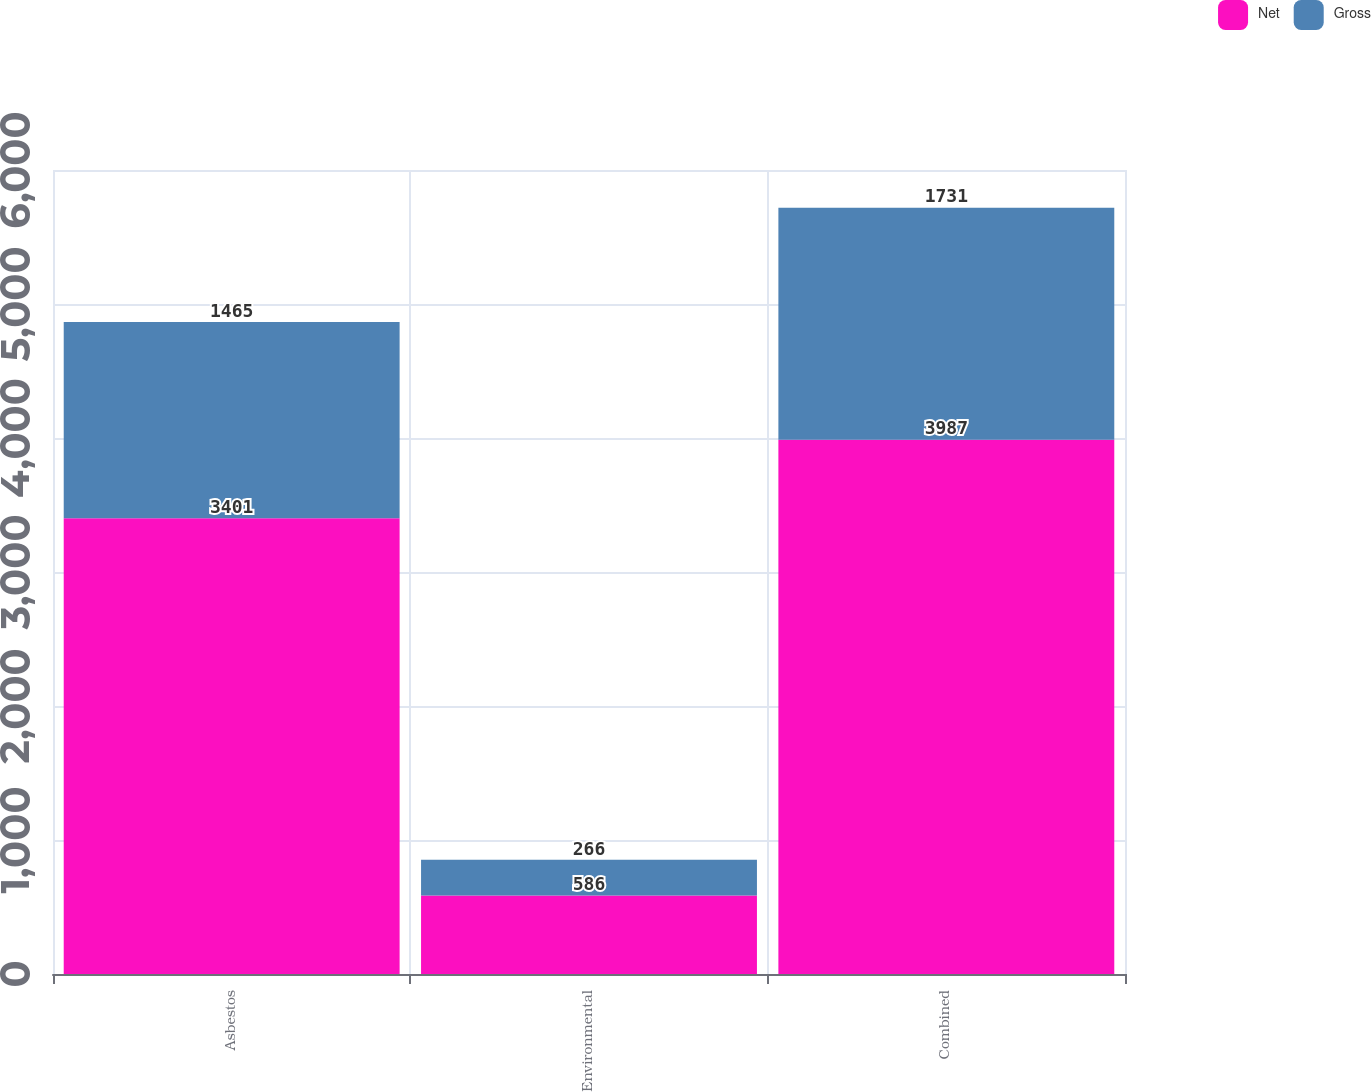Convert chart. <chart><loc_0><loc_0><loc_500><loc_500><stacked_bar_chart><ecel><fcel>Asbestos<fcel>Environmental<fcel>Combined<nl><fcel>Net<fcel>3401<fcel>586<fcel>3987<nl><fcel>Gross<fcel>1465<fcel>266<fcel>1731<nl></chart> 